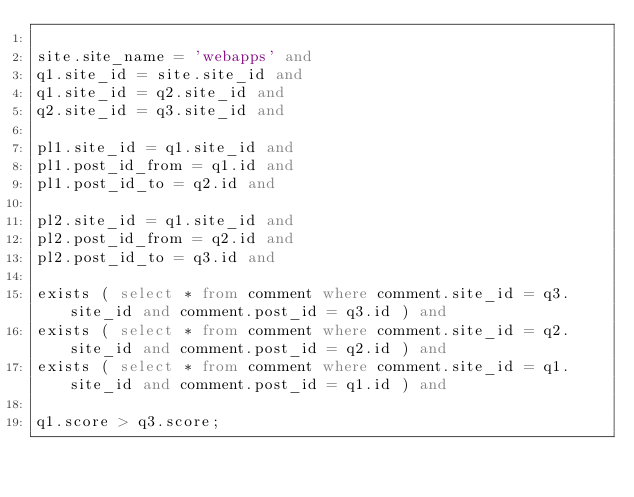<code> <loc_0><loc_0><loc_500><loc_500><_SQL_>
site.site_name = 'webapps' and
q1.site_id = site.site_id and
q1.site_id = q2.site_id and
q2.site_id = q3.site_id and

pl1.site_id = q1.site_id and
pl1.post_id_from = q1.id and
pl1.post_id_to = q2.id and

pl2.site_id = q1.site_id and
pl2.post_id_from = q2.id and
pl2.post_id_to = q3.id and

exists ( select * from comment where comment.site_id = q3.site_id and comment.post_id = q3.id ) and
exists ( select * from comment where comment.site_id = q2.site_id and comment.post_id = q2.id ) and
exists ( select * from comment where comment.site_id = q1.site_id and comment.post_id = q1.id ) and

q1.score > q3.score;
</code> 